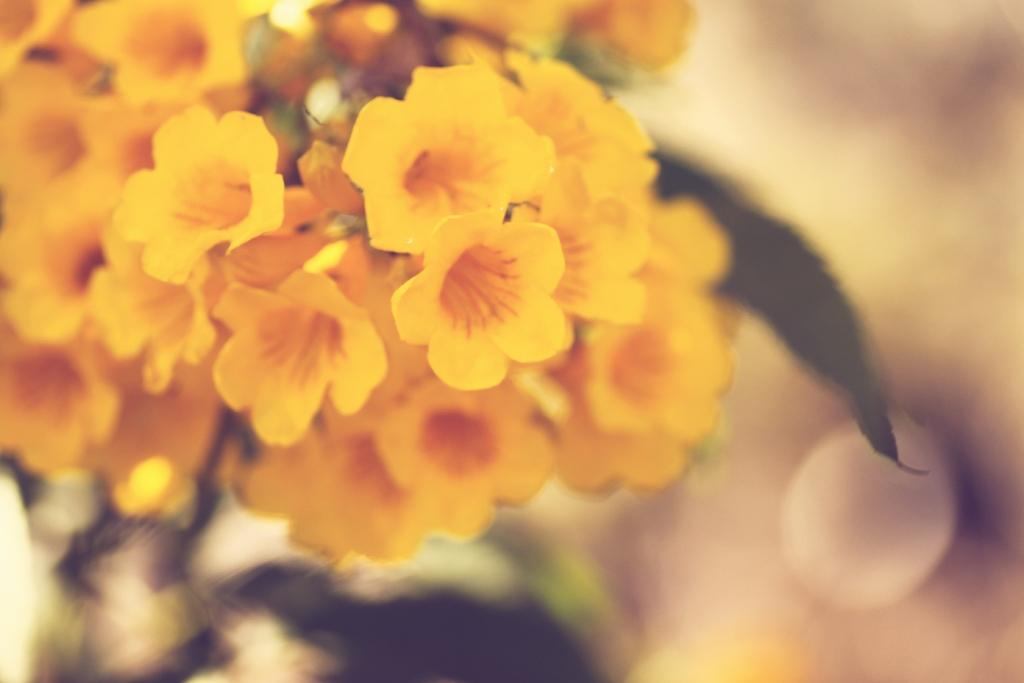What type of living organisms can be seen in the image? There are flowers in the image. Can you describe the background of the image? The background of the image is blurred. What color is the sock on the mother's foot in the image? There is no sock or mother present in the image; it only features flowers and a blurred background. 